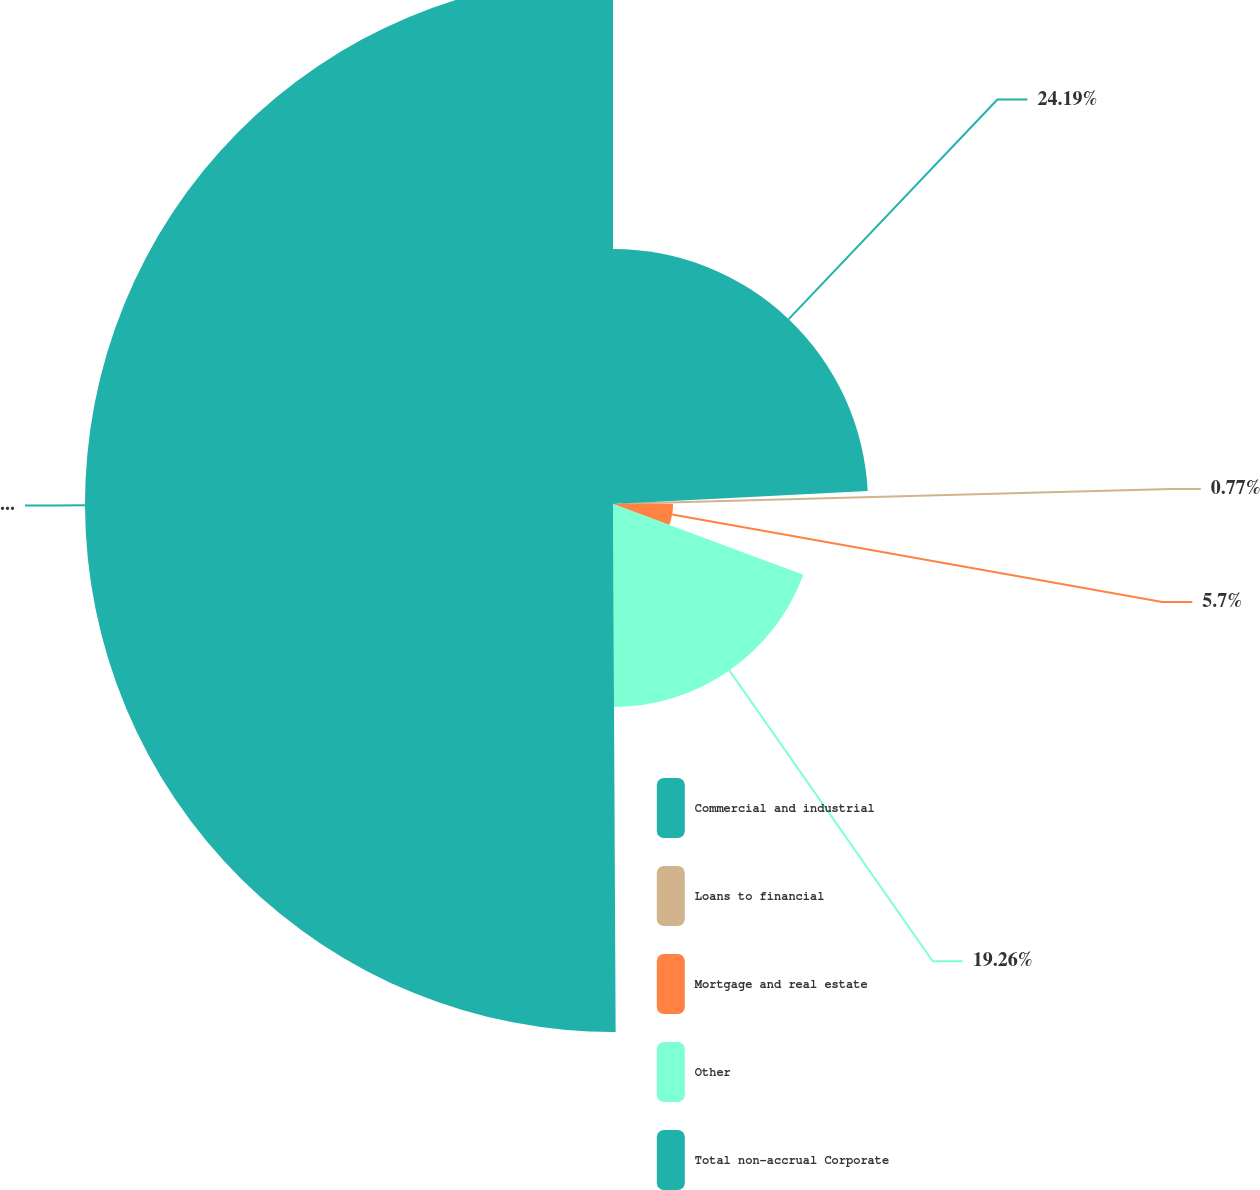Convert chart. <chart><loc_0><loc_0><loc_500><loc_500><pie_chart><fcel>Commercial and industrial<fcel>Loans to financial<fcel>Mortgage and real estate<fcel>Other<fcel>Total non-accrual Corporate<nl><fcel>24.19%<fcel>0.77%<fcel>5.7%<fcel>19.26%<fcel>50.08%<nl></chart> 